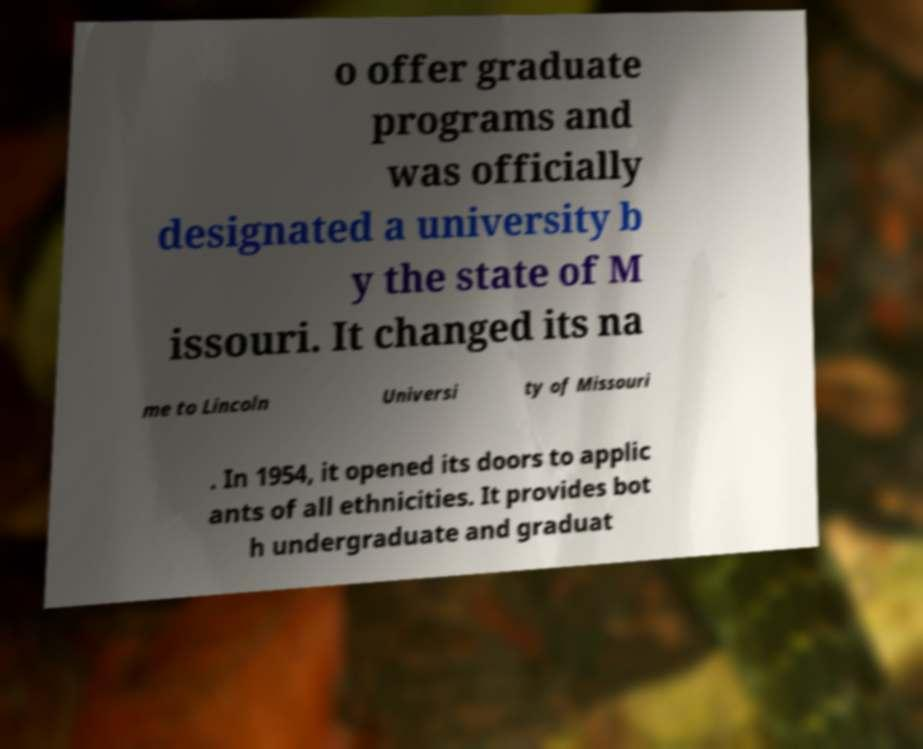Can you accurately transcribe the text from the provided image for me? o offer graduate programs and was officially designated a university b y the state of M issouri. It changed its na me to Lincoln Universi ty of Missouri . In 1954, it opened its doors to applic ants of all ethnicities. It provides bot h undergraduate and graduat 